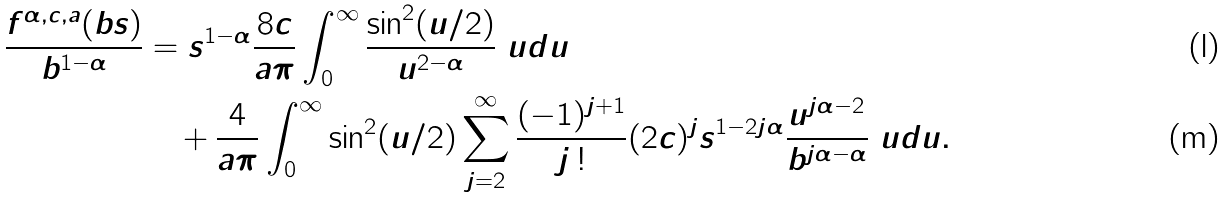Convert formula to latex. <formula><loc_0><loc_0><loc_500><loc_500>\frac { f ^ { \alpha , c , a } ( b s ) } { b ^ { 1 - \alpha } } & = s ^ { 1 - \alpha } \frac { 8 c } { a \pi } \int _ { 0 } ^ { \infty } \frac { \sin ^ { 2 } ( u / 2 ) } { u ^ { 2 - \alpha } } \ u d u \\ & \quad + \frac { 4 } { a \pi } \int _ { 0 } ^ { \infty } \sin ^ { 2 } ( u / 2 ) \sum _ { j = 2 } ^ { \infty } \frac { ( - 1 ) ^ { j + 1 } } { j \, ! } ( 2 c ) ^ { j } s ^ { 1 - 2 j \alpha } \frac { u ^ { j \alpha - 2 } } { b ^ { j \alpha - \alpha } } \ u d u .</formula> 